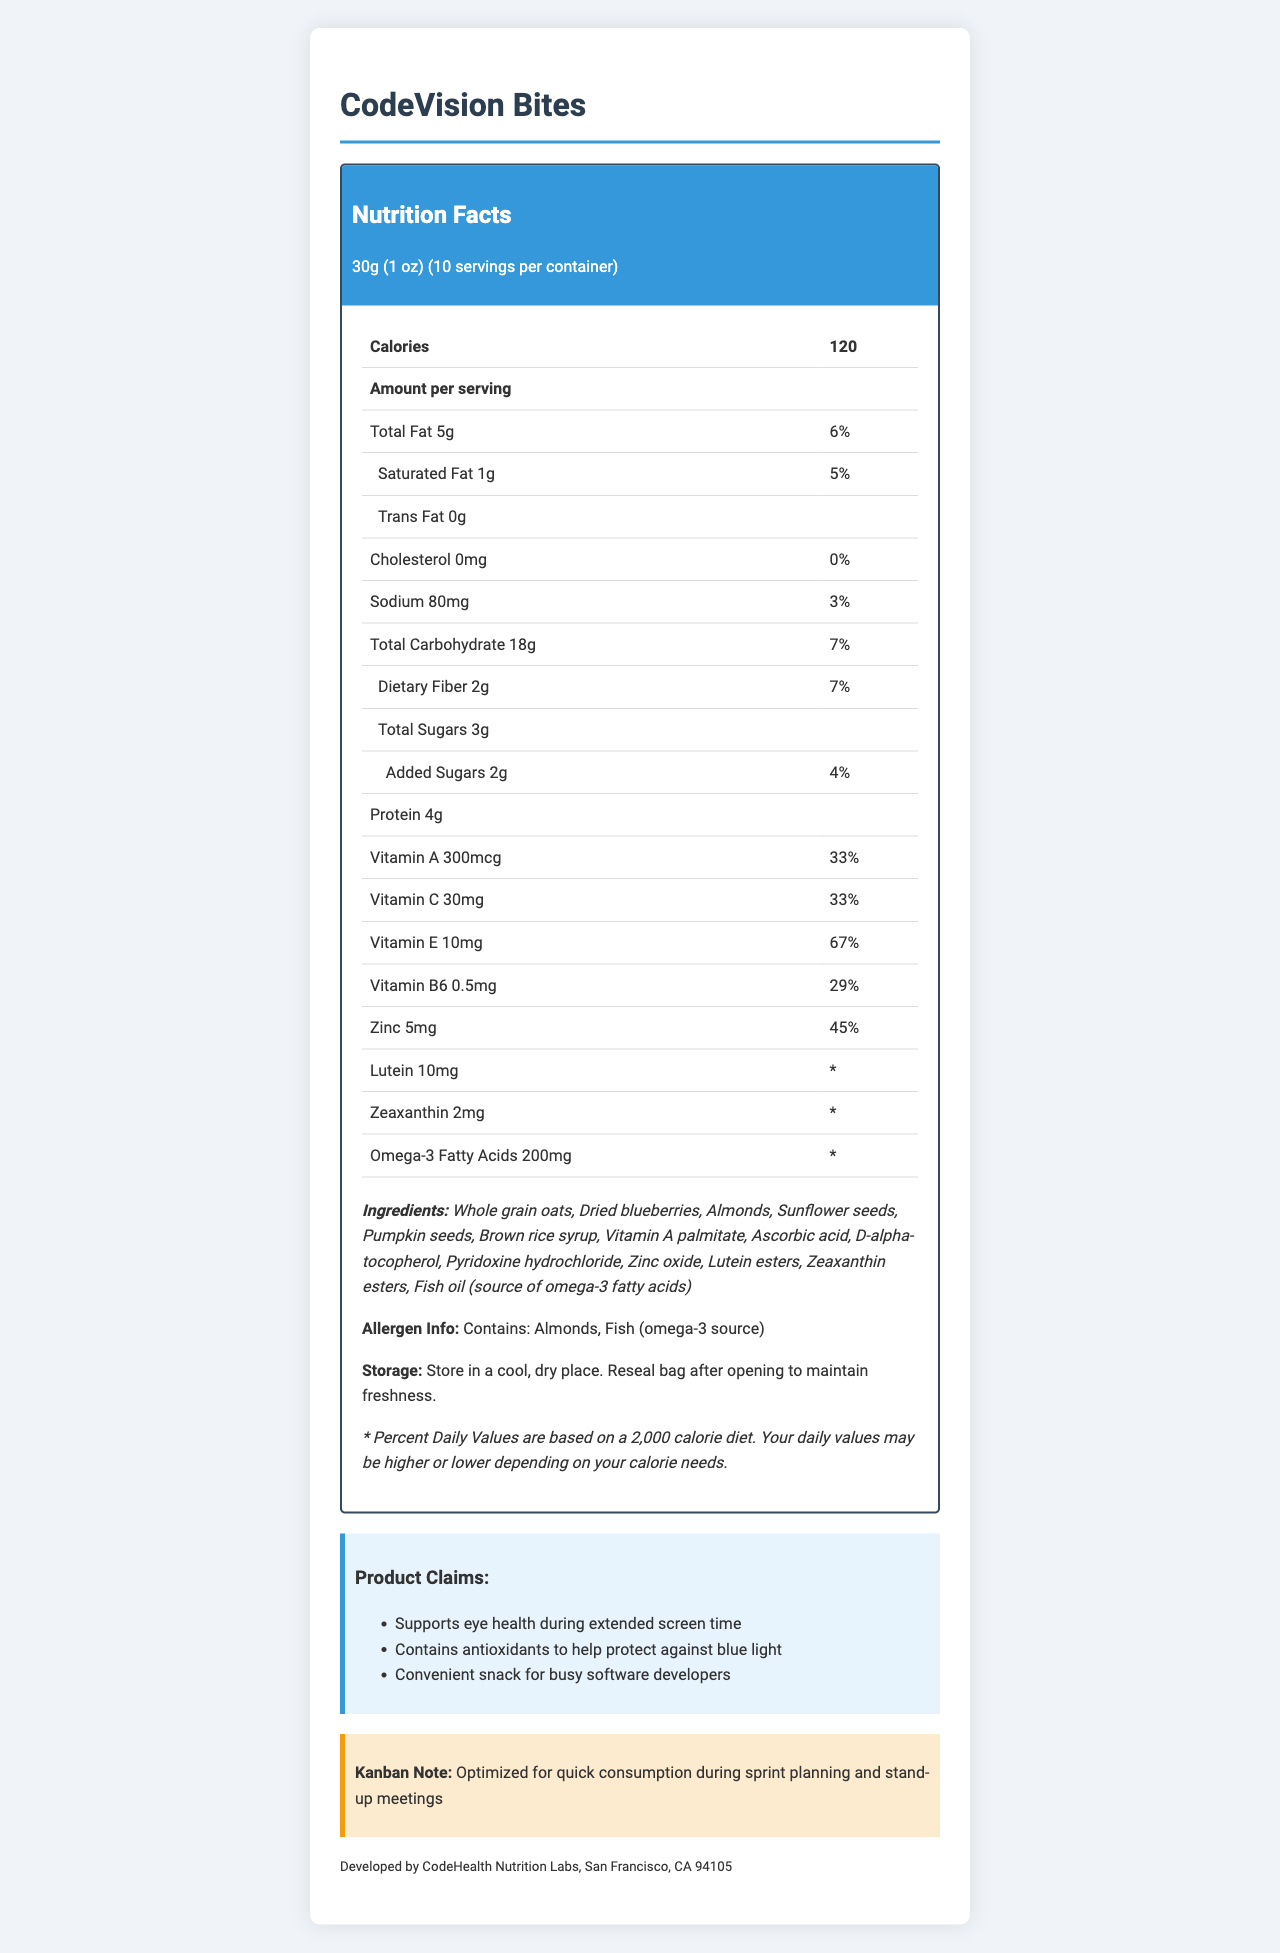what is the serving size of CodeVision Bites? The serving size is listed as 30g (1 oz) on the nutrition label.
Answer: 30g (1 oz) how many calories are in one serving of CodeVision Bites? The nutrition label states that one serving contains 120 calories.
Answer: 120 what is the percentage of Daily Value for Vitamin E in one serving? The nutrition label indicates that one serving of CodeVision Bites provides 67% of the Daily Value for Vitamin E.
Answer: 67% how many grams of dietary fiber are in a serving? The nutrition label shows that there are 2 grams of dietary fiber in one serving.
Answer: 2g what are the main ingredients of CodeVision Bites? These ingredients are listed in the ingredients section of the document.
Answer: Whole grain oats, Dried blueberries, Almonds, Sunflower seeds, Pumpkin seeds, Brown rice syrup, Vitamin A palmitate, Ascorbic acid, D-alpha-tocopherol, Pyridoxine hydrochloride, Zinc oxide, Lutein esters, Zeaxanthin esters, Fish oil (source of omega-3 fatty acids) which vitamins are included in CodeVision Bites that support eye health? A. Vitamin A, Vitamin C, Vitamin E B. Vitamin D, Vitamin K, Vitamin B12 C. Vitamin A, Vitamin D, Vitamin E The nutrition label lists Vitamin A, Vitamin C, and Vitamin E, all of which are known to support eye health.
Answer: A what allergens are present in CodeVision Bites? A. Gluten and Dairy B. Soy and Peanuts C. Almonds and Fish The allergen information section states that the product contains almonds and fish (omega-3 source).
Answer: C does CodeVision Bites contain any trans fat? The nutrition label shows that the trans fat content is 0g.
Answer: No what is the total amount of carbohydrates per serving? The nutrition label indicates that there are 18g of total carbohydrates per serving.
Answer: 18g is CodeVision Bites suitable for people with fish allergies? The allergen information states that the product contains fish (omega-3 source), making it unsuitable for people with fish allergies.
Answer: No what health benefits does CodeVision Bites offer for software developers? These claims are highlighted in the product claims section of the document.
Answer: Supports eye health during extended screen time, contains antioxidants to help protect against blue light, convenient snack for busy software developers how should CodeVision Bites be stored? The storage instructions specify that the product should be stored in a cool, dry place and the bag should be resealed after opening to maintain freshness.
Answer: Store in a cool, dry place. Reseal bag after opening to maintain freshness. summarize the main intent of the CodeVision Bites Nutrition Facts document. The document aims to inform consumers about the nutritional content and health benefits of CodeVision Bites, particularly for those who spend extended periods in front of screens.
Answer: The document provides detailed nutritional information for CodeVision Bites, a vitamin-enriched snack designed to support eye health. It includes data on serving size, calories, fats, vitamins, minerals, ingredients, allergen information, and storage instructions. It also emphasizes the product's benefits for software developers, including supporting eye health during long hours of screen time and containing antioxidants to protect against blue light. what is the amount of zeaxanthin per serving? The nutrition label lists the zeaxanthin content as 2mg per serving.
Answer: 2mg how many servings are there per container of CodeVision Bites? The document states that there are 10 servings per container.
Answer: 10 is CodeVision Bites suitable for vegetarians? The presence of fish oil as a source of omega-3 fatty acids suggests it may not be suitable for vegetarians, but the document does not explicitly address this.
Answer: Not enough information 